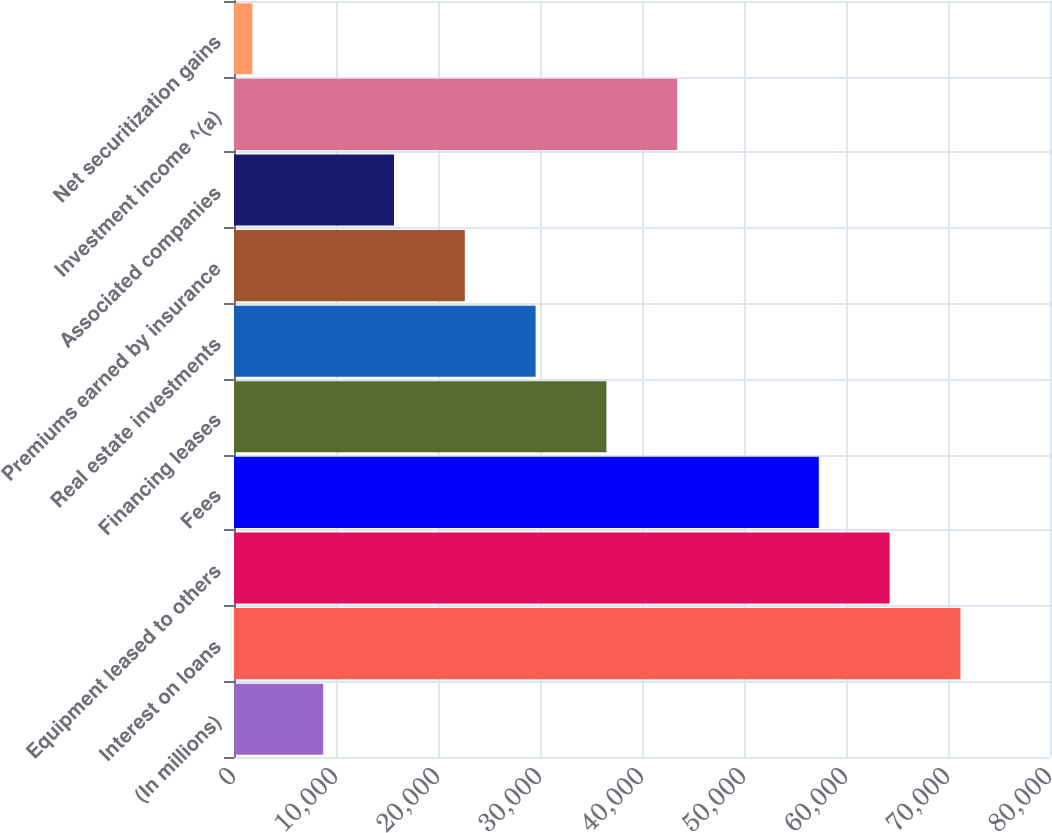Convert chart. <chart><loc_0><loc_0><loc_500><loc_500><bar_chart><fcel>(In millions)<fcel>Interest on loans<fcel>Equipment leased to others<fcel>Fees<fcel>Financing leases<fcel>Real estate investments<fcel>Premiums earned by insurance<fcel>Associated companies<fcel>Investment income ^(a)<fcel>Net securitization gains<nl><fcel>8745.4<fcel>71218<fcel>64276.6<fcel>57335.2<fcel>36511<fcel>29569.6<fcel>22628.2<fcel>15686.8<fcel>43452.4<fcel>1804<nl></chart> 